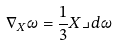<formula> <loc_0><loc_0><loc_500><loc_500>\nabla _ { X } \omega = \frac { 1 } { 3 } X \lrcorner d \omega</formula> 